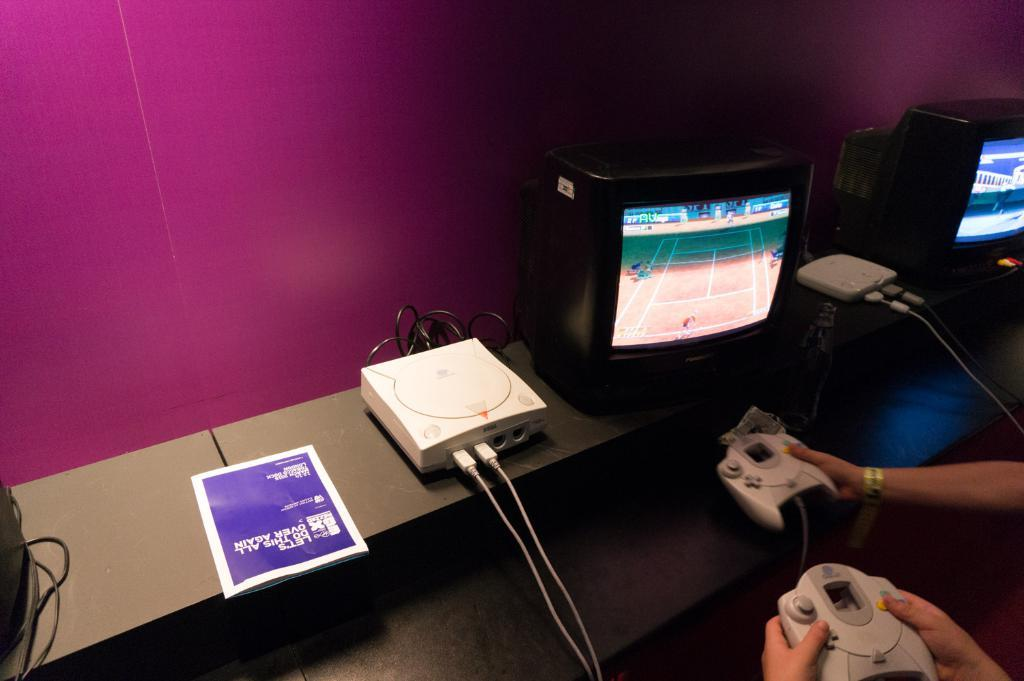Provide a one-sentence caption for the provided image. A magazine that says "Let's do this all over again" is next to people playing video games. 